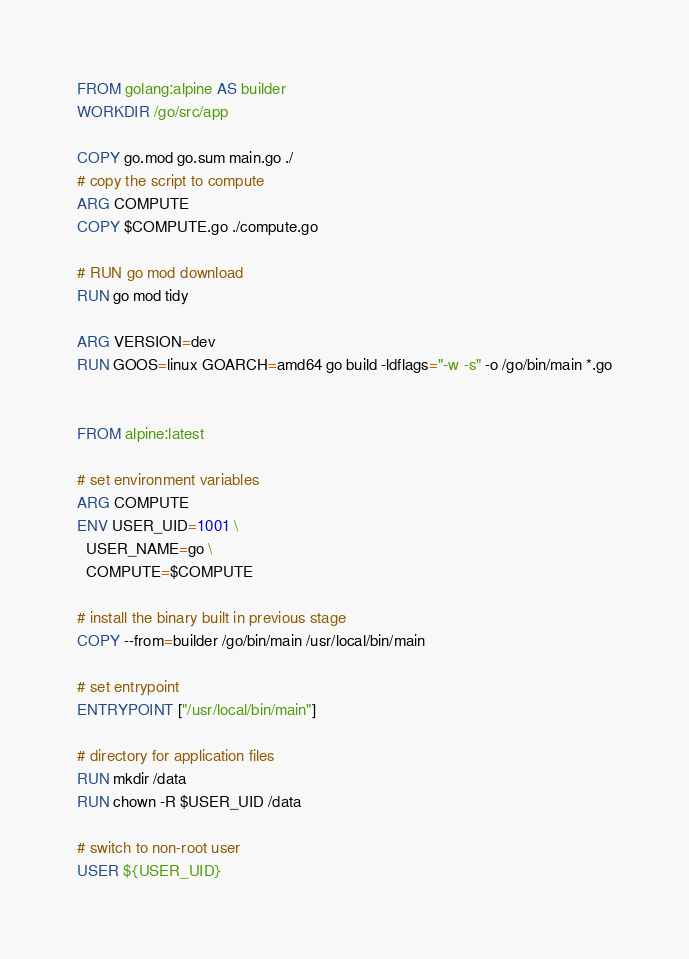Convert code to text. <code><loc_0><loc_0><loc_500><loc_500><_Dockerfile_>
FROM golang:alpine AS builder
WORKDIR /go/src/app

COPY go.mod go.sum main.go ./
# copy the script to compute
ARG COMPUTE
COPY $COMPUTE.go ./compute.go

# RUN go mod download
RUN go mod tidy

ARG VERSION=dev
RUN GOOS=linux GOARCH=amd64 go build -ldflags="-w -s" -o /go/bin/main *.go


FROM alpine:latest

# set environment variables
ARG COMPUTE
ENV USER_UID=1001 \
  USER_NAME=go \
  COMPUTE=$COMPUTE

# install the binary built in previous stage
COPY --from=builder /go/bin/main /usr/local/bin/main

# set entrypoint
ENTRYPOINT ["/usr/local/bin/main"]

# directory for application files
RUN mkdir /data
RUN chown -R $USER_UID /data

# switch to non-root user
USER ${USER_UID}

</code> 